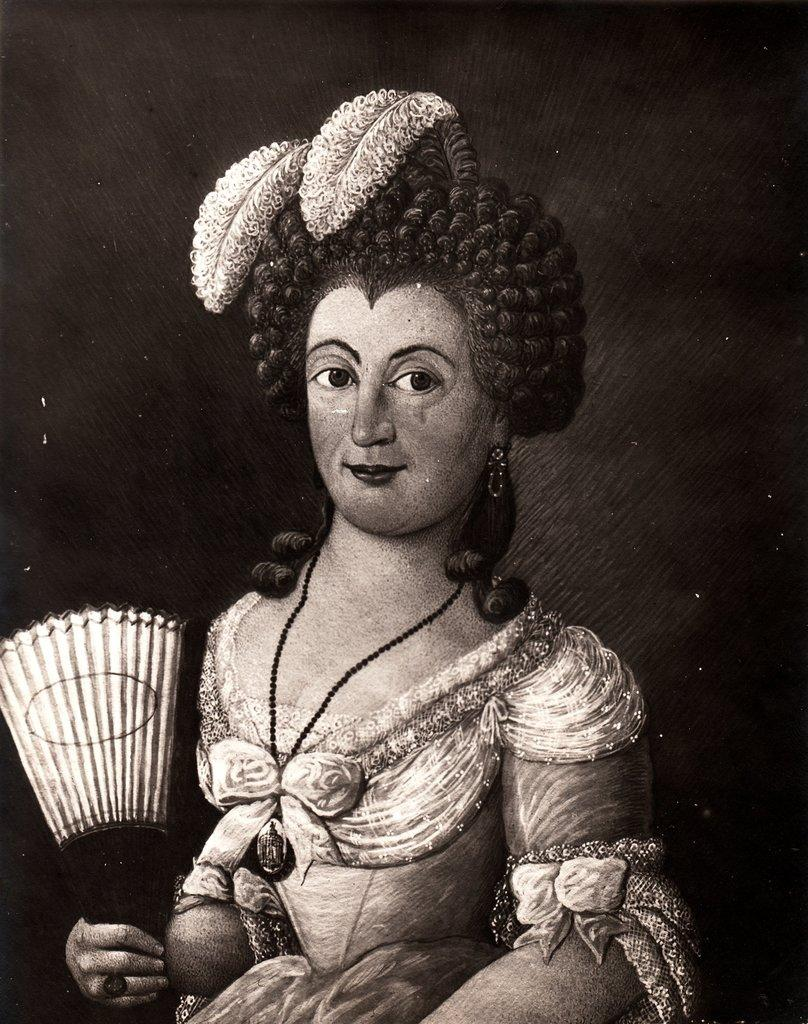What type of artwork is depicted in the image? The image appears to be a painting. Who is the main subject in the painting? There is a woman in the center of the painting. What is the woman holding in the painting? The woman is holding a hand fan. What is the woman wearing in the painting? The woman is wearing a dress. What expression does the woman have in the painting? The woman is smiling. How would you describe the background of the painting? The background of the painting is very dark. What type of sheet is used to create the texture of the woman's dress in the painting? There is no information about the materials or techniques used to create the painting, so we cannot determine the type of sheet used for the dress. How is the glue used to attach the woman's smile to her face in the painting? There is no glue or any other adhesive mentioned in the painting, and the woman's smile is a natural part of her expression. What type of eggnog is being served in the painting? There is no mention of eggnog or any other food or drink in the painting. 